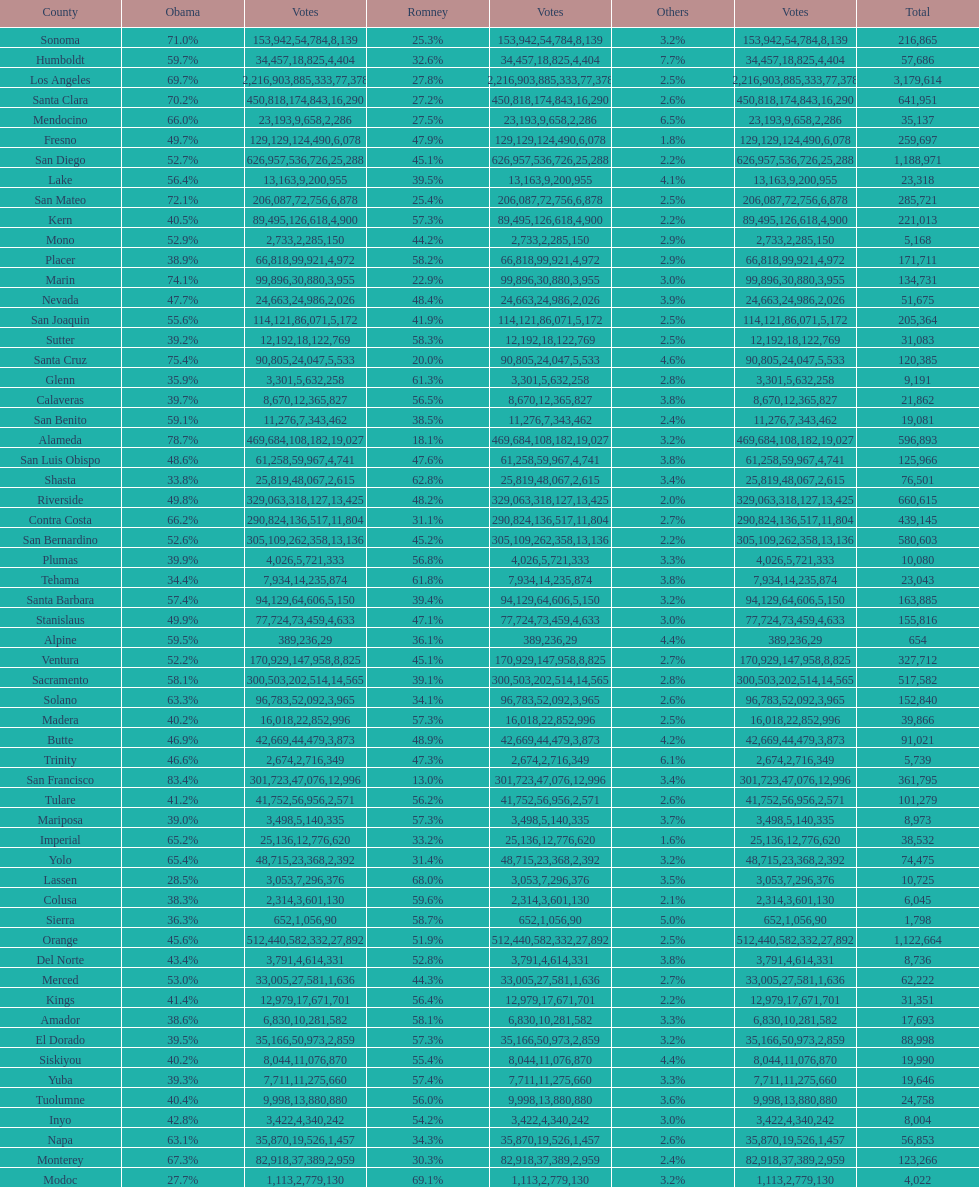Which county had the lower percentage votes for obama: amador, humboldt, or lake? Amador. 